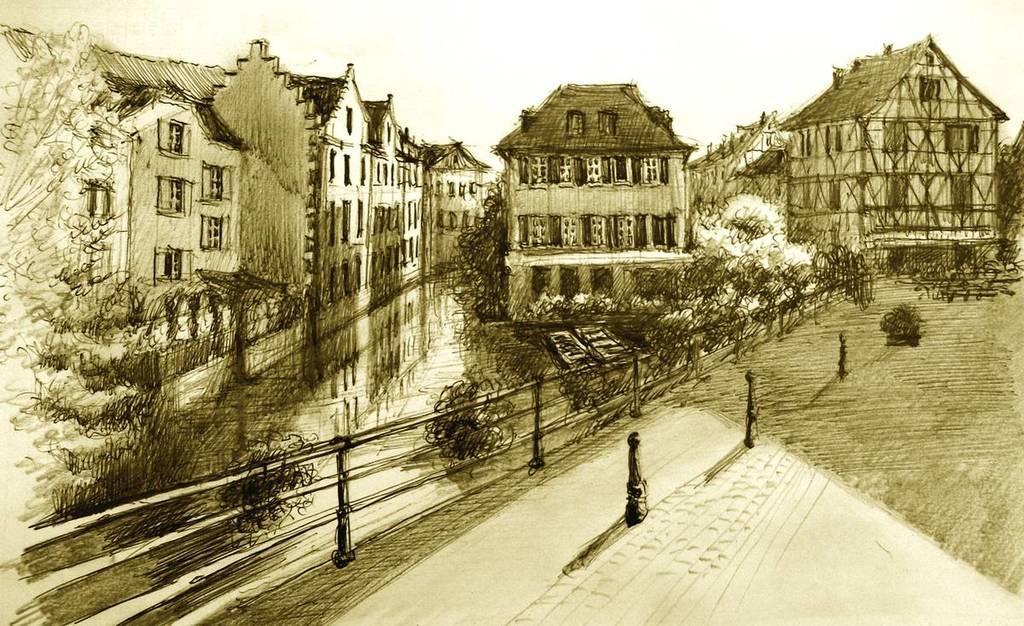Describe this image in one or two sentences. In the picture I can see sketch of some trees, fencing and building. 